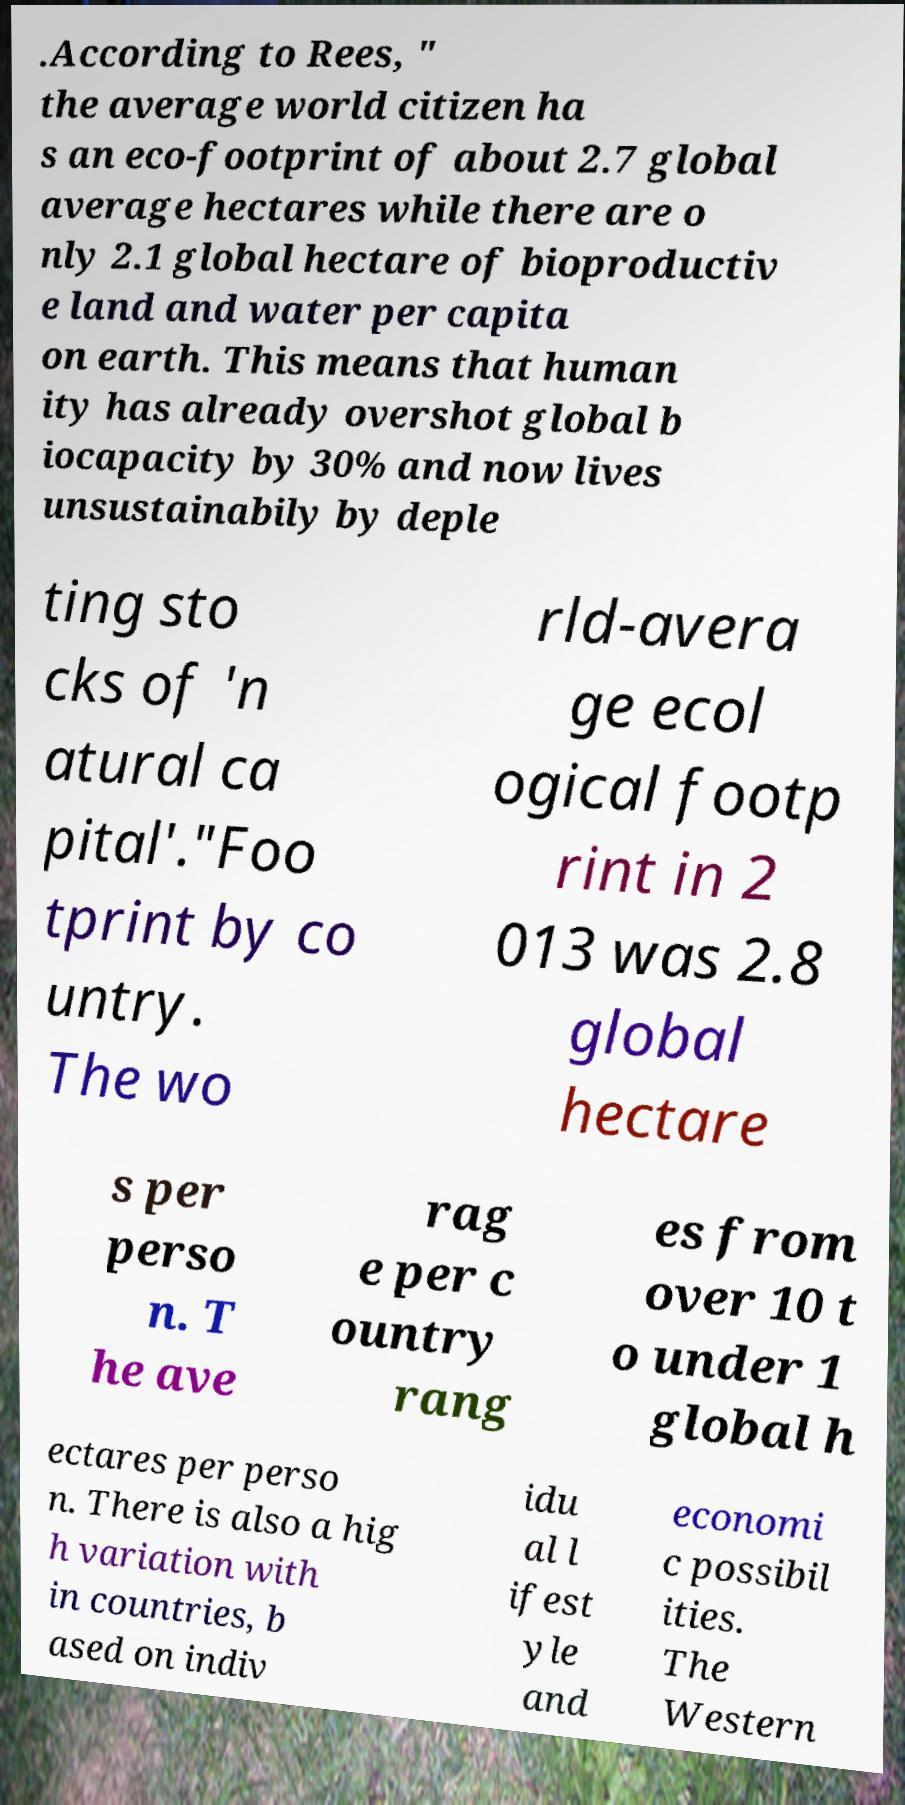Could you extract and type out the text from this image? .According to Rees, " the average world citizen ha s an eco-footprint of about 2.7 global average hectares while there are o nly 2.1 global hectare of bioproductiv e land and water per capita on earth. This means that human ity has already overshot global b iocapacity by 30% and now lives unsustainabily by deple ting sto cks of 'n atural ca pital'."Foo tprint by co untry. The wo rld-avera ge ecol ogical footp rint in 2 013 was 2.8 global hectare s per perso n. T he ave rag e per c ountry rang es from over 10 t o under 1 global h ectares per perso n. There is also a hig h variation with in countries, b ased on indiv idu al l ifest yle and economi c possibil ities. The Western 